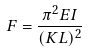<formula> <loc_0><loc_0><loc_500><loc_500>F = \frac { \pi ^ { 2 } E I } { ( K L ) ^ { 2 } }</formula> 